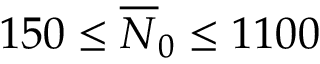<formula> <loc_0><loc_0><loc_500><loc_500>1 5 0 \leq \overline { N } _ { 0 } \leq 1 1 0 0</formula> 